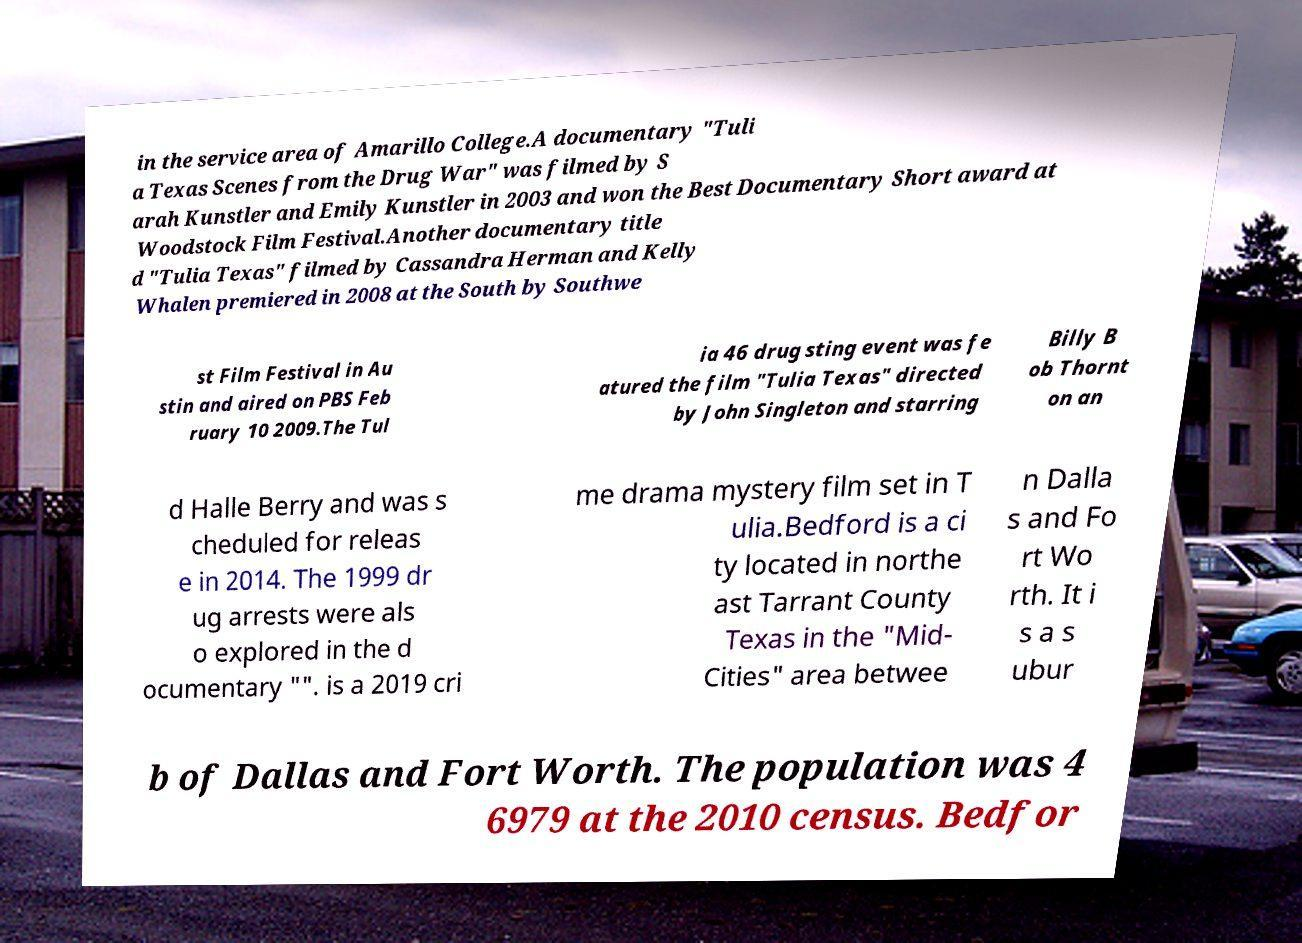Can you accurately transcribe the text from the provided image for me? in the service area of Amarillo College.A documentary "Tuli a Texas Scenes from the Drug War" was filmed by S arah Kunstler and Emily Kunstler in 2003 and won the Best Documentary Short award at Woodstock Film Festival.Another documentary title d "Tulia Texas" filmed by Cassandra Herman and Kelly Whalen premiered in 2008 at the South by Southwe st Film Festival in Au stin and aired on PBS Feb ruary 10 2009.The Tul ia 46 drug sting event was fe atured the film "Tulia Texas" directed by John Singleton and starring Billy B ob Thornt on an d Halle Berry and was s cheduled for releas e in 2014. The 1999 dr ug arrests were als o explored in the d ocumentary "". is a 2019 cri me drama mystery film set in T ulia.Bedford is a ci ty located in northe ast Tarrant County Texas in the "Mid- Cities" area betwee n Dalla s and Fo rt Wo rth. It i s a s ubur b of Dallas and Fort Worth. The population was 4 6979 at the 2010 census. Bedfor 